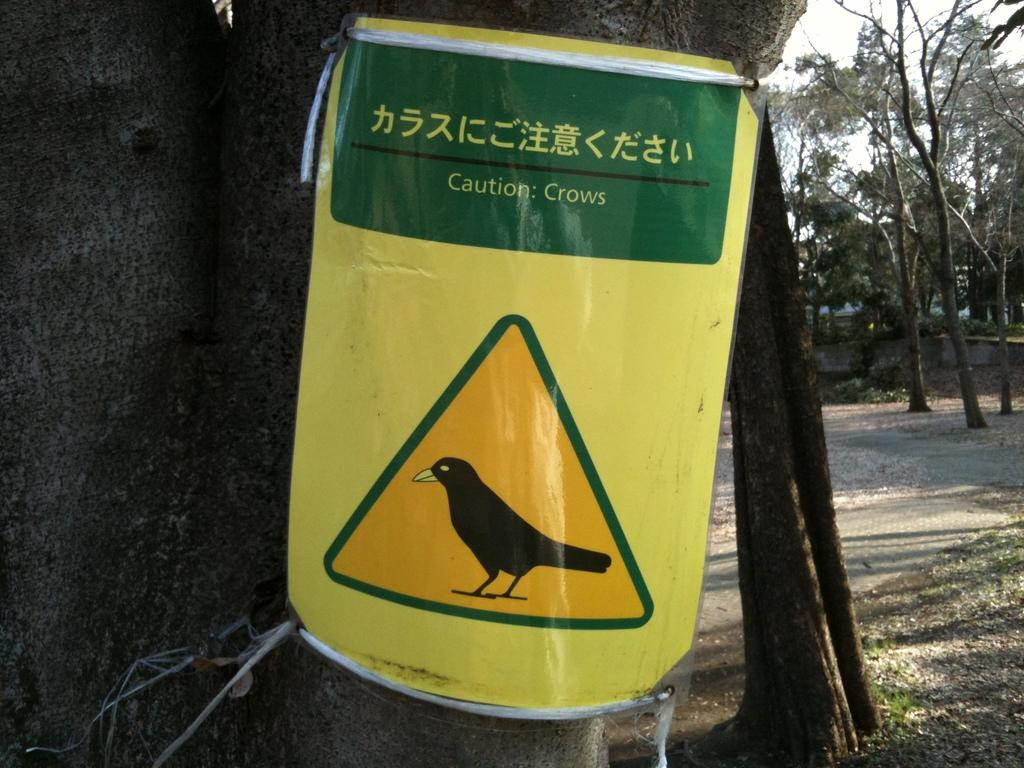What is located at the front of the image? There is a poster with text and an image in the front of the image. What can be seen in the background of the image? There are trees in the background of the image. What type of vegetation is on the ground? There is grass on the ground. Where is the duck playing in the image? There is no duck present in the image. Can you describe the playground in the image? There is no playground present in the image. 